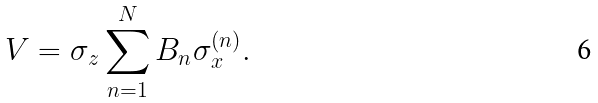<formula> <loc_0><loc_0><loc_500><loc_500>V = \sigma _ { z } \sum _ { n = 1 } ^ { N } B _ { n } \sigma ^ { ( n ) } _ { x } .</formula> 